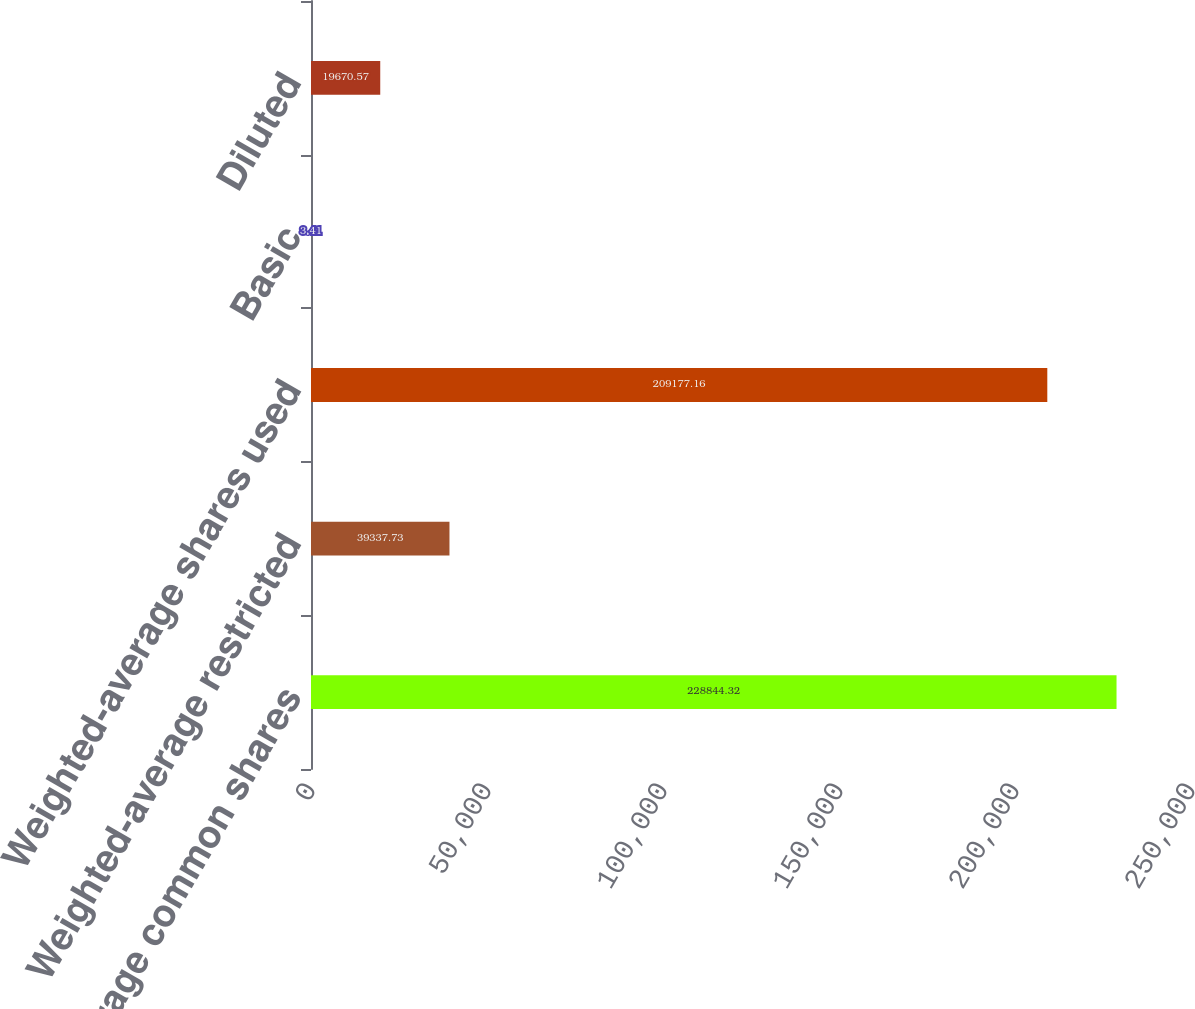Convert chart. <chart><loc_0><loc_0><loc_500><loc_500><bar_chart><fcel>Weighted-average common shares<fcel>Weighted-average restricted<fcel>Weighted-average shares used<fcel>Basic<fcel>Diluted<nl><fcel>228844<fcel>39337.7<fcel>209177<fcel>3.41<fcel>19670.6<nl></chart> 